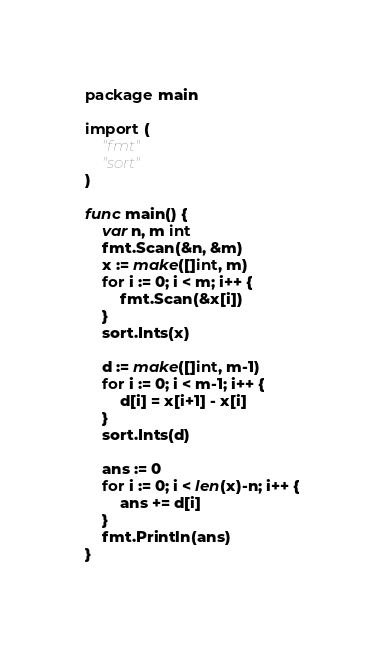Convert code to text. <code><loc_0><loc_0><loc_500><loc_500><_Go_>package main

import (
	"fmt"
	"sort"
)

func main() {
	var n, m int
	fmt.Scan(&n, &m)
	x := make([]int, m)
	for i := 0; i < m; i++ {
		fmt.Scan(&x[i])
	}
	sort.Ints(x)

	d := make([]int, m-1)
	for i := 0; i < m-1; i++ {
		d[i] = x[i+1] - x[i]
	}
	sort.Ints(d)

	ans := 0
	for i := 0; i < len(x)-n; i++ {
		ans += d[i]
	}
	fmt.Println(ans)
}
</code> 